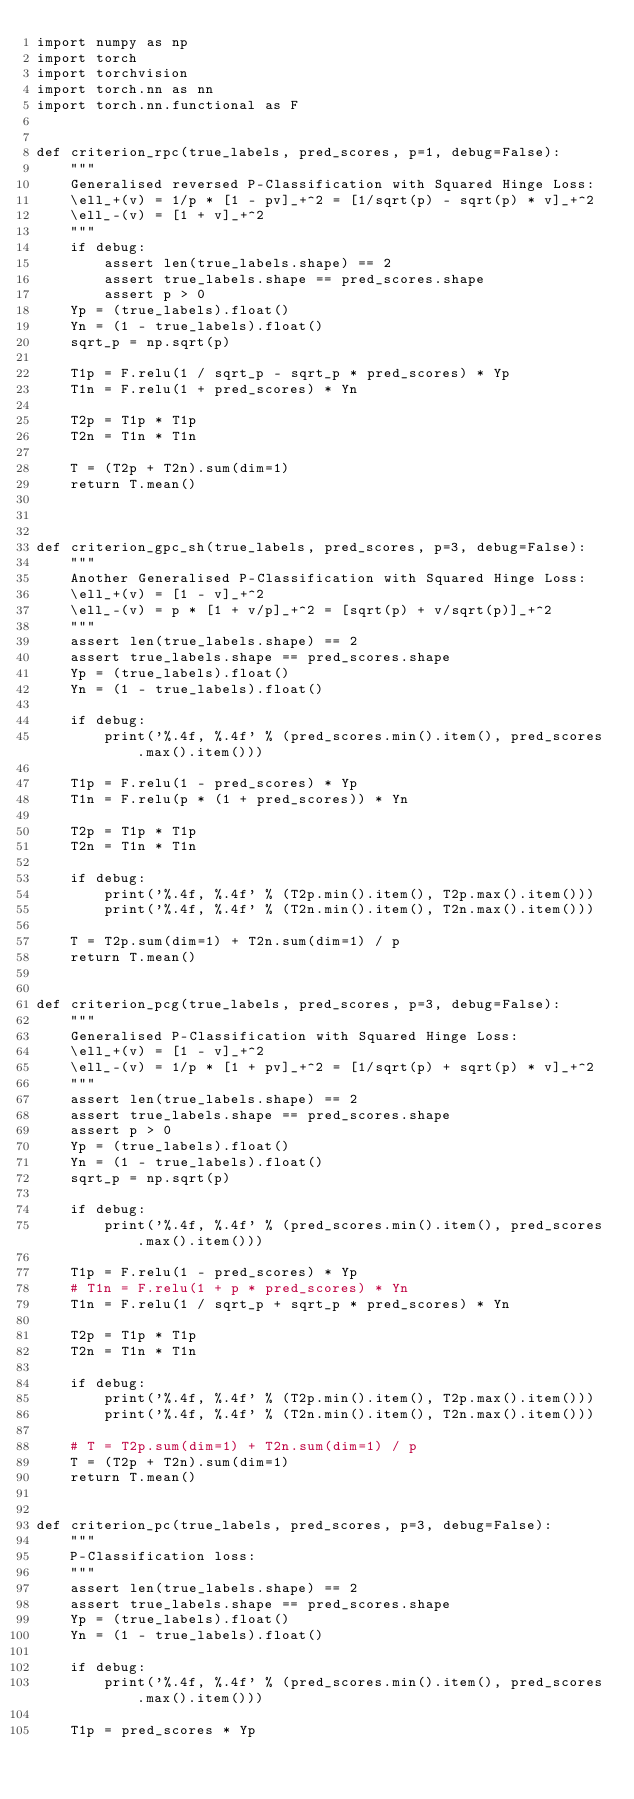Convert code to text. <code><loc_0><loc_0><loc_500><loc_500><_Python_>import numpy as np
import torch
import torchvision
import torch.nn as nn
import torch.nn.functional as F


def criterion_rpc(true_labels, pred_scores, p=1, debug=False):
    """
    Generalised reversed P-Classification with Squared Hinge Loss:
    \ell_+(v) = 1/p * [1 - pv]_+^2 = [1/sqrt(p) - sqrt(p) * v]_+^2
    \ell_-(v) = [1 + v]_+^2
    """
    if debug:
        assert len(true_labels.shape) == 2
        assert true_labels.shape == pred_scores.shape
        assert p > 0
    Yp = (true_labels).float()
    Yn = (1 - true_labels).float()
    sqrt_p = np.sqrt(p)
    
    T1p = F.relu(1 / sqrt_p - sqrt_p * pred_scores) * Yp
    T1n = F.relu(1 + pred_scores) * Yn
    
    T2p = T1p * T1p
    T2n = T1n * T1n
    
    T = (T2p + T2n).sum(dim=1)
    return T.mean()



def criterion_gpc_sh(true_labels, pred_scores, p=3, debug=False):
    """
    Another Generalised P-Classification with Squared Hinge Loss:
    \ell_+(v) = [1 - v]_+^2 
    \ell_-(v) = p * [1 + v/p]_+^2 = [sqrt(p) + v/sqrt(p)]_+^2
    """
    assert len(true_labels.shape) == 2
    assert true_labels.shape == pred_scores.shape
    Yp = (true_labels).float()
    Yn = (1 - true_labels).float()
    
    if debug:
        print('%.4f, %.4f' % (pred_scores.min().item(), pred_scores.max().item()))
    
    T1p = F.relu(1 - pred_scores) * Yp
    T1n = F.relu(p * (1 + pred_scores)) * Yn
    
    T2p = T1p * T1p
    T2n = T1n * T1n
    
    if debug:
        print('%.4f, %.4f' % (T2p.min().item(), T2p.max().item()))
        print('%.4f, %.4f' % (T2n.min().item(), T2n.max().item()))
    
    T = T2p.sum(dim=1) + T2n.sum(dim=1) / p
    return T.mean()


def criterion_pcg(true_labels, pred_scores, p=3, debug=False):
    """
    Generalised P-Classification with Squared Hinge Loss:
    \ell_+(v) = [1 - v]_+^2 
    \ell_-(v) = 1/p * [1 + pv]_+^2 = [1/sqrt(p) + sqrt(p) * v]_+^2
    """
    assert len(true_labels.shape) == 2
    assert true_labels.shape == pred_scores.shape
    assert p > 0
    Yp = (true_labels).float()
    Yn = (1 - true_labels).float()
    sqrt_p = np.sqrt(p)
    
    if debug:
        print('%.4f, %.4f' % (pred_scores.min().item(), pred_scores.max().item()))
    
    T1p = F.relu(1 - pred_scores) * Yp
    # T1n = F.relu(1 + p * pred_scores) * Yn
    T1n = F.relu(1 / sqrt_p + sqrt_p * pred_scores) * Yn
    
    T2p = T1p * T1p
    T2n = T1n * T1n
    
    if debug:
        print('%.4f, %.4f' % (T2p.min().item(), T2p.max().item()))
        print('%.4f, %.4f' % (T2n.min().item(), T2n.max().item()))
    
    # T = T2p.sum(dim=1) + T2n.sum(dim=1) / p
    T = (T2p + T2n).sum(dim=1)
    return T.mean()


def criterion_pc(true_labels, pred_scores, p=3, debug=False):
    """
    P-Classification loss: 
    """
    assert len(true_labels.shape) == 2
    assert true_labels.shape == pred_scores.shape
    Yp = (true_labels).float()
    Yn = (1 - true_labels).float()
    
    if debug:
        print('%.4f, %.4f' % (pred_scores.min().item(), pred_scores.max().item()))
    
    T1p = pred_scores * Yp</code> 